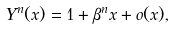Convert formula to latex. <formula><loc_0><loc_0><loc_500><loc_500>Y ^ { n } ( x ) = 1 + \beta ^ { n } x + o ( x ) ,</formula> 